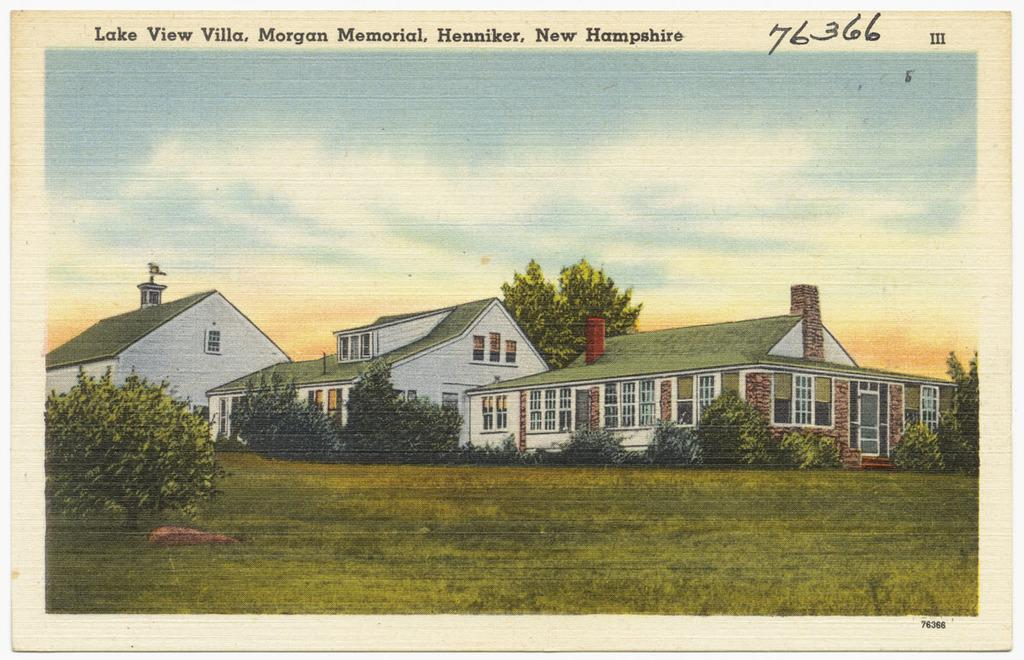What type of image is being described? The image is a photograph. What can be seen in the photograph? There are buildings and trees in the image. Is there any text present in the photograph? Yes, there is text at the top of the image. What is visible at the bottom of the image? There is ground visible at the bottom of the image. How many jellyfish can be seen swimming in the water in the image? There are no jellyfish or water present in the image; it features buildings, trees, text, and ground. What type of monkey is sitting on the tree branch in the image? There are no monkeys or tree branches present in the image; it features buildings, trees, text, and ground. 